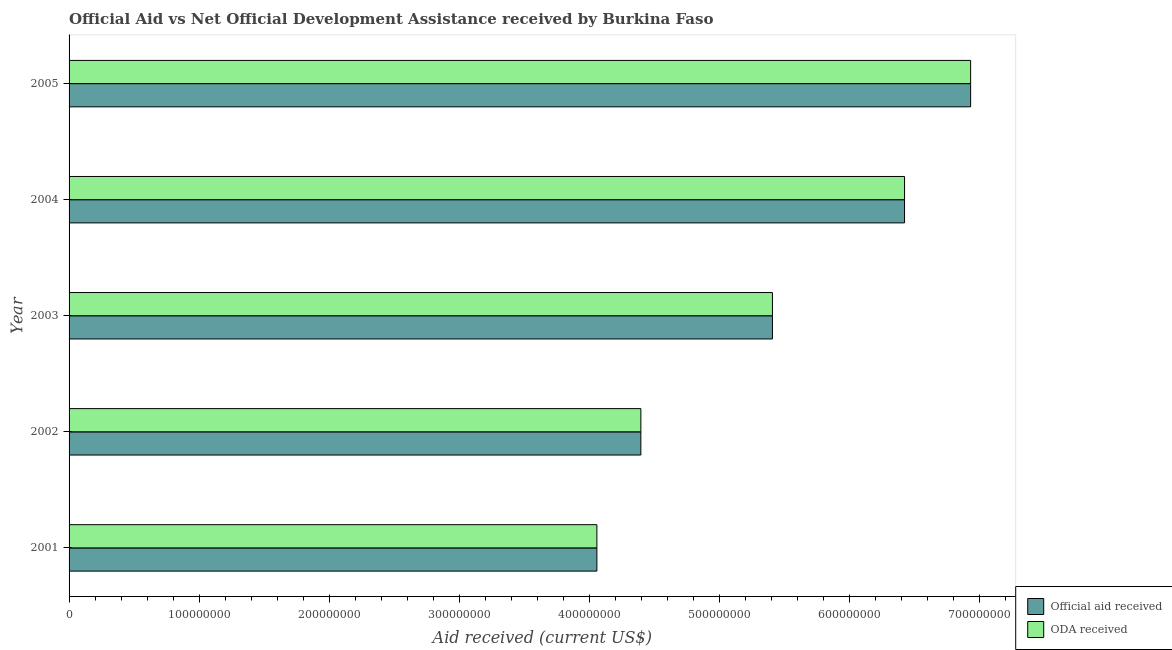Are the number of bars on each tick of the Y-axis equal?
Ensure brevity in your answer.  Yes. How many bars are there on the 3rd tick from the top?
Your response must be concise. 2. How many bars are there on the 2nd tick from the bottom?
Make the answer very short. 2. What is the official aid received in 2001?
Offer a terse response. 4.06e+08. Across all years, what is the maximum official aid received?
Ensure brevity in your answer.  6.93e+08. Across all years, what is the minimum oda received?
Offer a terse response. 4.06e+08. In which year was the oda received maximum?
Provide a short and direct response. 2005. In which year was the official aid received minimum?
Your answer should be compact. 2001. What is the total official aid received in the graph?
Make the answer very short. 2.72e+09. What is the difference between the oda received in 2004 and that in 2005?
Offer a very short reply. -5.08e+07. What is the difference between the official aid received in 2001 and the oda received in 2003?
Provide a succinct answer. -1.35e+08. What is the average official aid received per year?
Make the answer very short. 5.45e+08. In the year 2005, what is the difference between the official aid received and oda received?
Ensure brevity in your answer.  0. What is the ratio of the oda received in 2004 to that in 2005?
Your answer should be very brief. 0.93. Is the difference between the official aid received in 2002 and 2005 greater than the difference between the oda received in 2002 and 2005?
Keep it short and to the point. No. What is the difference between the highest and the second highest oda received?
Provide a short and direct response. 5.08e+07. What is the difference between the highest and the lowest official aid received?
Your answer should be compact. 2.87e+08. In how many years, is the oda received greater than the average oda received taken over all years?
Offer a terse response. 2. What does the 2nd bar from the top in 2002 represents?
Offer a very short reply. Official aid received. What does the 2nd bar from the bottom in 2003 represents?
Offer a terse response. ODA received. How many bars are there?
Give a very brief answer. 10. Are all the bars in the graph horizontal?
Ensure brevity in your answer.  Yes. How many years are there in the graph?
Provide a short and direct response. 5. Are the values on the major ticks of X-axis written in scientific E-notation?
Your response must be concise. No. Where does the legend appear in the graph?
Offer a terse response. Bottom right. How are the legend labels stacked?
Your answer should be compact. Vertical. What is the title of the graph?
Provide a short and direct response. Official Aid vs Net Official Development Assistance received by Burkina Faso . What is the label or title of the X-axis?
Make the answer very short. Aid received (current US$). What is the Aid received (current US$) in Official aid received in 2001?
Offer a very short reply. 4.06e+08. What is the Aid received (current US$) of ODA received in 2001?
Your answer should be compact. 4.06e+08. What is the Aid received (current US$) of Official aid received in 2002?
Your answer should be compact. 4.40e+08. What is the Aid received (current US$) in ODA received in 2002?
Ensure brevity in your answer.  4.40e+08. What is the Aid received (current US$) in Official aid received in 2003?
Offer a very short reply. 5.41e+08. What is the Aid received (current US$) of ODA received in 2003?
Provide a short and direct response. 5.41e+08. What is the Aid received (current US$) in Official aid received in 2004?
Offer a terse response. 6.43e+08. What is the Aid received (current US$) of ODA received in 2004?
Provide a succinct answer. 6.43e+08. What is the Aid received (current US$) in Official aid received in 2005?
Make the answer very short. 6.93e+08. What is the Aid received (current US$) of ODA received in 2005?
Your answer should be very brief. 6.93e+08. Across all years, what is the maximum Aid received (current US$) in Official aid received?
Ensure brevity in your answer.  6.93e+08. Across all years, what is the maximum Aid received (current US$) in ODA received?
Provide a short and direct response. 6.93e+08. Across all years, what is the minimum Aid received (current US$) of Official aid received?
Offer a very short reply. 4.06e+08. Across all years, what is the minimum Aid received (current US$) of ODA received?
Ensure brevity in your answer.  4.06e+08. What is the total Aid received (current US$) of Official aid received in the graph?
Give a very brief answer. 2.72e+09. What is the total Aid received (current US$) in ODA received in the graph?
Ensure brevity in your answer.  2.72e+09. What is the difference between the Aid received (current US$) in Official aid received in 2001 and that in 2002?
Your answer should be very brief. -3.38e+07. What is the difference between the Aid received (current US$) in ODA received in 2001 and that in 2002?
Keep it short and to the point. -3.38e+07. What is the difference between the Aid received (current US$) in Official aid received in 2001 and that in 2003?
Your answer should be compact. -1.35e+08. What is the difference between the Aid received (current US$) in ODA received in 2001 and that in 2003?
Your answer should be compact. -1.35e+08. What is the difference between the Aid received (current US$) in Official aid received in 2001 and that in 2004?
Provide a short and direct response. -2.37e+08. What is the difference between the Aid received (current US$) of ODA received in 2001 and that in 2004?
Your answer should be very brief. -2.37e+08. What is the difference between the Aid received (current US$) of Official aid received in 2001 and that in 2005?
Offer a very short reply. -2.87e+08. What is the difference between the Aid received (current US$) of ODA received in 2001 and that in 2005?
Your answer should be compact. -2.87e+08. What is the difference between the Aid received (current US$) of Official aid received in 2002 and that in 2003?
Your answer should be compact. -1.01e+08. What is the difference between the Aid received (current US$) of ODA received in 2002 and that in 2003?
Make the answer very short. -1.01e+08. What is the difference between the Aid received (current US$) of Official aid received in 2002 and that in 2004?
Offer a terse response. -2.03e+08. What is the difference between the Aid received (current US$) of ODA received in 2002 and that in 2004?
Ensure brevity in your answer.  -2.03e+08. What is the difference between the Aid received (current US$) of Official aid received in 2002 and that in 2005?
Offer a terse response. -2.54e+08. What is the difference between the Aid received (current US$) in ODA received in 2002 and that in 2005?
Give a very brief answer. -2.54e+08. What is the difference between the Aid received (current US$) in Official aid received in 2003 and that in 2004?
Offer a very short reply. -1.02e+08. What is the difference between the Aid received (current US$) of ODA received in 2003 and that in 2004?
Keep it short and to the point. -1.02e+08. What is the difference between the Aid received (current US$) of Official aid received in 2003 and that in 2005?
Offer a terse response. -1.52e+08. What is the difference between the Aid received (current US$) in ODA received in 2003 and that in 2005?
Your answer should be compact. -1.52e+08. What is the difference between the Aid received (current US$) in Official aid received in 2004 and that in 2005?
Offer a terse response. -5.08e+07. What is the difference between the Aid received (current US$) in ODA received in 2004 and that in 2005?
Keep it short and to the point. -5.08e+07. What is the difference between the Aid received (current US$) in Official aid received in 2001 and the Aid received (current US$) in ODA received in 2002?
Your response must be concise. -3.38e+07. What is the difference between the Aid received (current US$) of Official aid received in 2001 and the Aid received (current US$) of ODA received in 2003?
Give a very brief answer. -1.35e+08. What is the difference between the Aid received (current US$) in Official aid received in 2001 and the Aid received (current US$) in ODA received in 2004?
Keep it short and to the point. -2.37e+08. What is the difference between the Aid received (current US$) of Official aid received in 2001 and the Aid received (current US$) of ODA received in 2005?
Keep it short and to the point. -2.87e+08. What is the difference between the Aid received (current US$) in Official aid received in 2002 and the Aid received (current US$) in ODA received in 2003?
Your response must be concise. -1.01e+08. What is the difference between the Aid received (current US$) of Official aid received in 2002 and the Aid received (current US$) of ODA received in 2004?
Ensure brevity in your answer.  -2.03e+08. What is the difference between the Aid received (current US$) in Official aid received in 2002 and the Aid received (current US$) in ODA received in 2005?
Provide a succinct answer. -2.54e+08. What is the difference between the Aid received (current US$) in Official aid received in 2003 and the Aid received (current US$) in ODA received in 2004?
Offer a very short reply. -1.02e+08. What is the difference between the Aid received (current US$) of Official aid received in 2003 and the Aid received (current US$) of ODA received in 2005?
Keep it short and to the point. -1.52e+08. What is the difference between the Aid received (current US$) in Official aid received in 2004 and the Aid received (current US$) in ODA received in 2005?
Make the answer very short. -5.08e+07. What is the average Aid received (current US$) of Official aid received per year?
Your answer should be compact. 5.45e+08. What is the average Aid received (current US$) of ODA received per year?
Your answer should be compact. 5.45e+08. In the year 2001, what is the difference between the Aid received (current US$) of Official aid received and Aid received (current US$) of ODA received?
Provide a short and direct response. 0. In the year 2002, what is the difference between the Aid received (current US$) of Official aid received and Aid received (current US$) of ODA received?
Offer a very short reply. 0. In the year 2003, what is the difference between the Aid received (current US$) in Official aid received and Aid received (current US$) in ODA received?
Offer a very short reply. 0. In the year 2005, what is the difference between the Aid received (current US$) of Official aid received and Aid received (current US$) of ODA received?
Keep it short and to the point. 0. What is the ratio of the Aid received (current US$) of ODA received in 2001 to that in 2002?
Offer a terse response. 0.92. What is the ratio of the Aid received (current US$) of Official aid received in 2001 to that in 2003?
Offer a very short reply. 0.75. What is the ratio of the Aid received (current US$) of ODA received in 2001 to that in 2003?
Offer a very short reply. 0.75. What is the ratio of the Aid received (current US$) in Official aid received in 2001 to that in 2004?
Your response must be concise. 0.63. What is the ratio of the Aid received (current US$) in ODA received in 2001 to that in 2004?
Provide a short and direct response. 0.63. What is the ratio of the Aid received (current US$) in Official aid received in 2001 to that in 2005?
Your answer should be compact. 0.59. What is the ratio of the Aid received (current US$) in ODA received in 2001 to that in 2005?
Provide a short and direct response. 0.59. What is the ratio of the Aid received (current US$) in Official aid received in 2002 to that in 2003?
Your answer should be very brief. 0.81. What is the ratio of the Aid received (current US$) of ODA received in 2002 to that in 2003?
Provide a short and direct response. 0.81. What is the ratio of the Aid received (current US$) in Official aid received in 2002 to that in 2004?
Offer a very short reply. 0.68. What is the ratio of the Aid received (current US$) in ODA received in 2002 to that in 2004?
Give a very brief answer. 0.68. What is the ratio of the Aid received (current US$) in Official aid received in 2002 to that in 2005?
Your answer should be compact. 0.63. What is the ratio of the Aid received (current US$) of ODA received in 2002 to that in 2005?
Your answer should be compact. 0.63. What is the ratio of the Aid received (current US$) in Official aid received in 2003 to that in 2004?
Provide a short and direct response. 0.84. What is the ratio of the Aid received (current US$) of ODA received in 2003 to that in 2004?
Give a very brief answer. 0.84. What is the ratio of the Aid received (current US$) of Official aid received in 2003 to that in 2005?
Make the answer very short. 0.78. What is the ratio of the Aid received (current US$) of ODA received in 2003 to that in 2005?
Give a very brief answer. 0.78. What is the ratio of the Aid received (current US$) of Official aid received in 2004 to that in 2005?
Offer a terse response. 0.93. What is the ratio of the Aid received (current US$) in ODA received in 2004 to that in 2005?
Your answer should be very brief. 0.93. What is the difference between the highest and the second highest Aid received (current US$) in Official aid received?
Your response must be concise. 5.08e+07. What is the difference between the highest and the second highest Aid received (current US$) of ODA received?
Make the answer very short. 5.08e+07. What is the difference between the highest and the lowest Aid received (current US$) in Official aid received?
Provide a succinct answer. 2.87e+08. What is the difference between the highest and the lowest Aid received (current US$) of ODA received?
Offer a very short reply. 2.87e+08. 